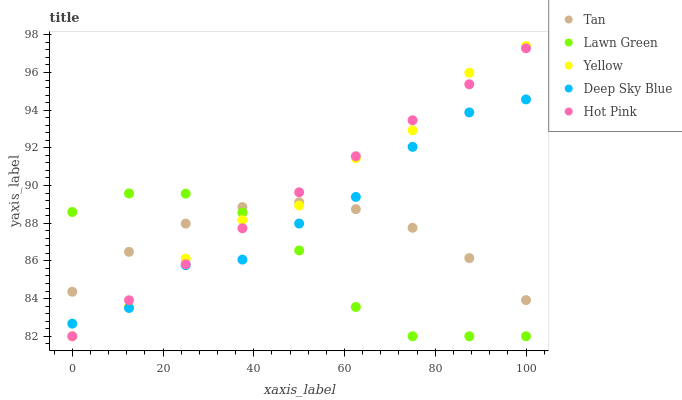Does Lawn Green have the minimum area under the curve?
Answer yes or no. Yes. Does Hot Pink have the maximum area under the curve?
Answer yes or no. Yes. Does Tan have the minimum area under the curve?
Answer yes or no. No. Does Tan have the maximum area under the curve?
Answer yes or no. No. Is Hot Pink the smoothest?
Answer yes or no. Yes. Is Deep Sky Blue the roughest?
Answer yes or no. Yes. Is Tan the smoothest?
Answer yes or no. No. Is Tan the roughest?
Answer yes or no. No. Does Lawn Green have the lowest value?
Answer yes or no. Yes. Does Tan have the lowest value?
Answer yes or no. No. Does Yellow have the highest value?
Answer yes or no. Yes. Does Hot Pink have the highest value?
Answer yes or no. No. Does Yellow intersect Lawn Green?
Answer yes or no. Yes. Is Yellow less than Lawn Green?
Answer yes or no. No. Is Yellow greater than Lawn Green?
Answer yes or no. No. 